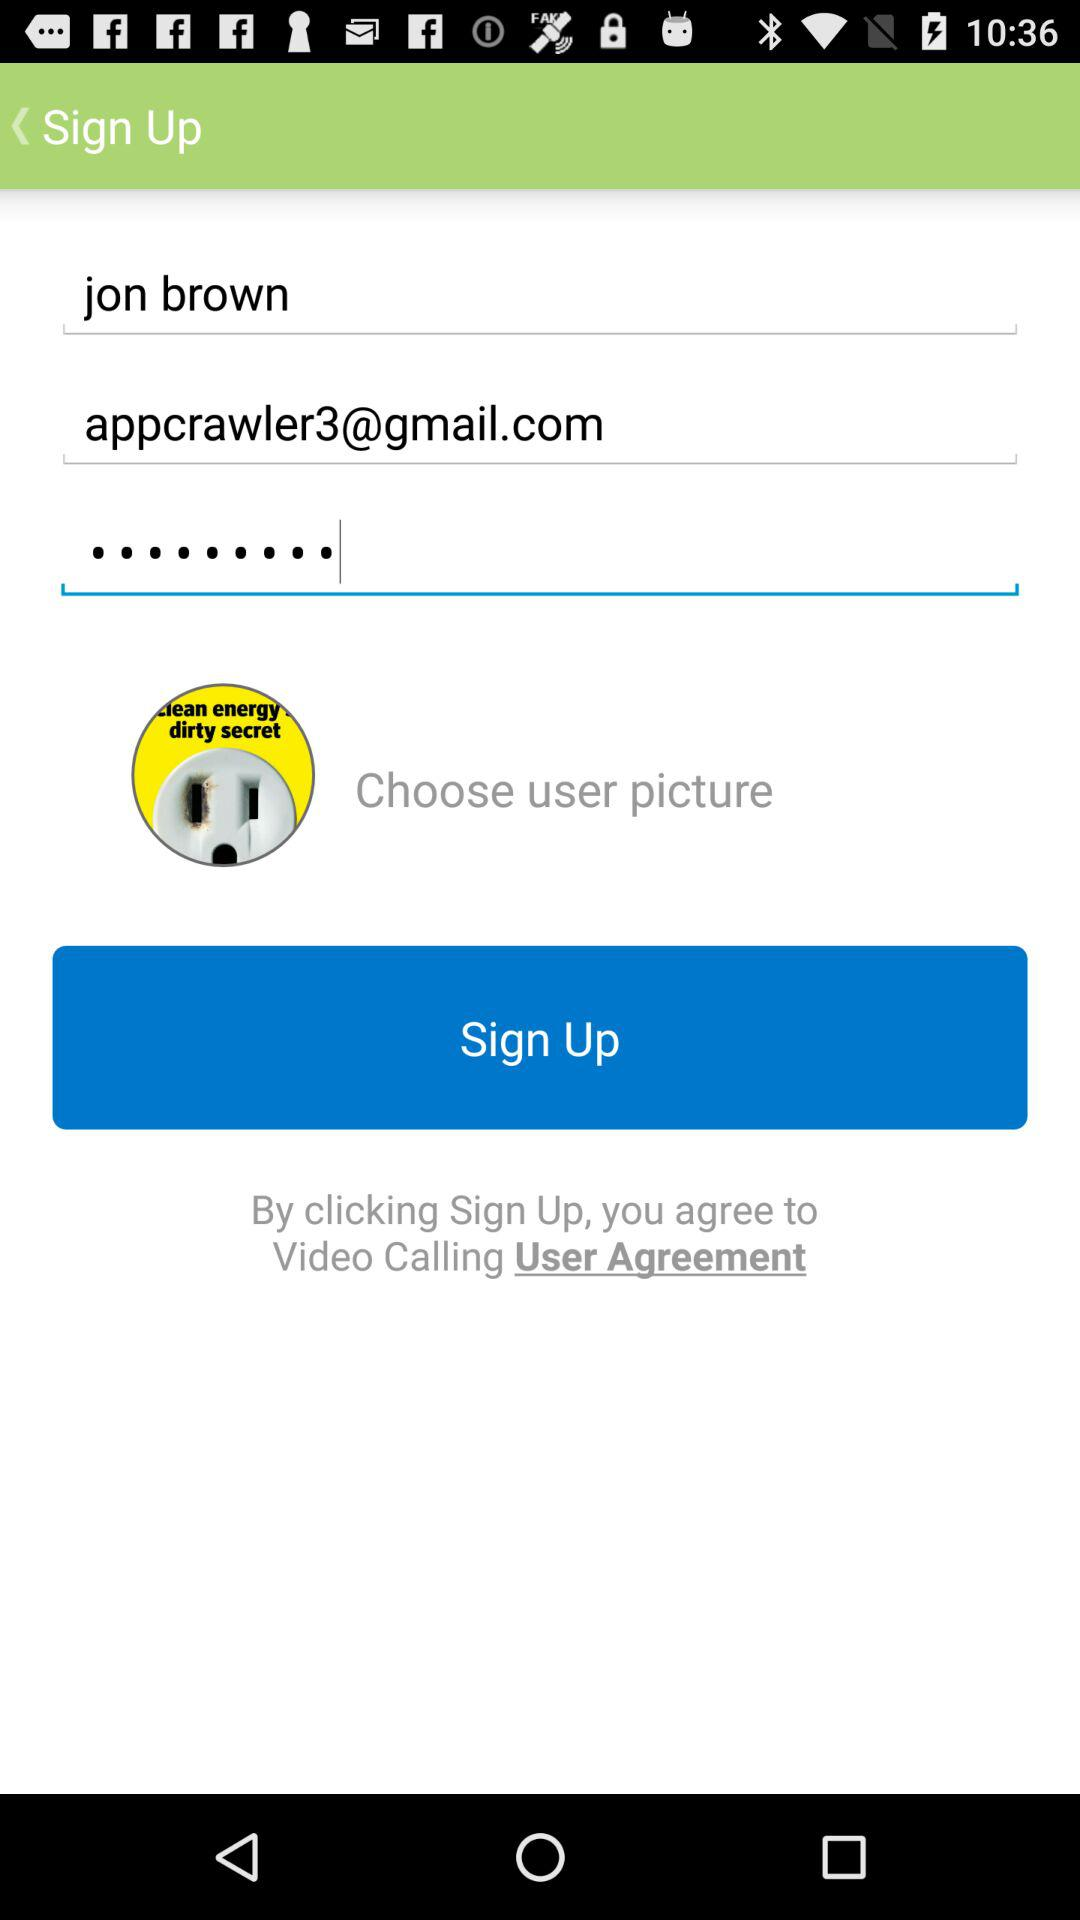What is the user name? The user name is Jon Brown. 